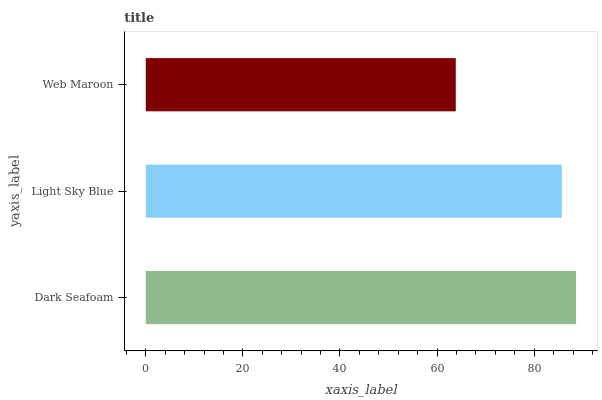Is Web Maroon the minimum?
Answer yes or no. Yes. Is Dark Seafoam the maximum?
Answer yes or no. Yes. Is Light Sky Blue the minimum?
Answer yes or no. No. Is Light Sky Blue the maximum?
Answer yes or no. No. Is Dark Seafoam greater than Light Sky Blue?
Answer yes or no. Yes. Is Light Sky Blue less than Dark Seafoam?
Answer yes or no. Yes. Is Light Sky Blue greater than Dark Seafoam?
Answer yes or no. No. Is Dark Seafoam less than Light Sky Blue?
Answer yes or no. No. Is Light Sky Blue the high median?
Answer yes or no. Yes. Is Light Sky Blue the low median?
Answer yes or no. Yes. Is Web Maroon the high median?
Answer yes or no. No. Is Dark Seafoam the low median?
Answer yes or no. No. 